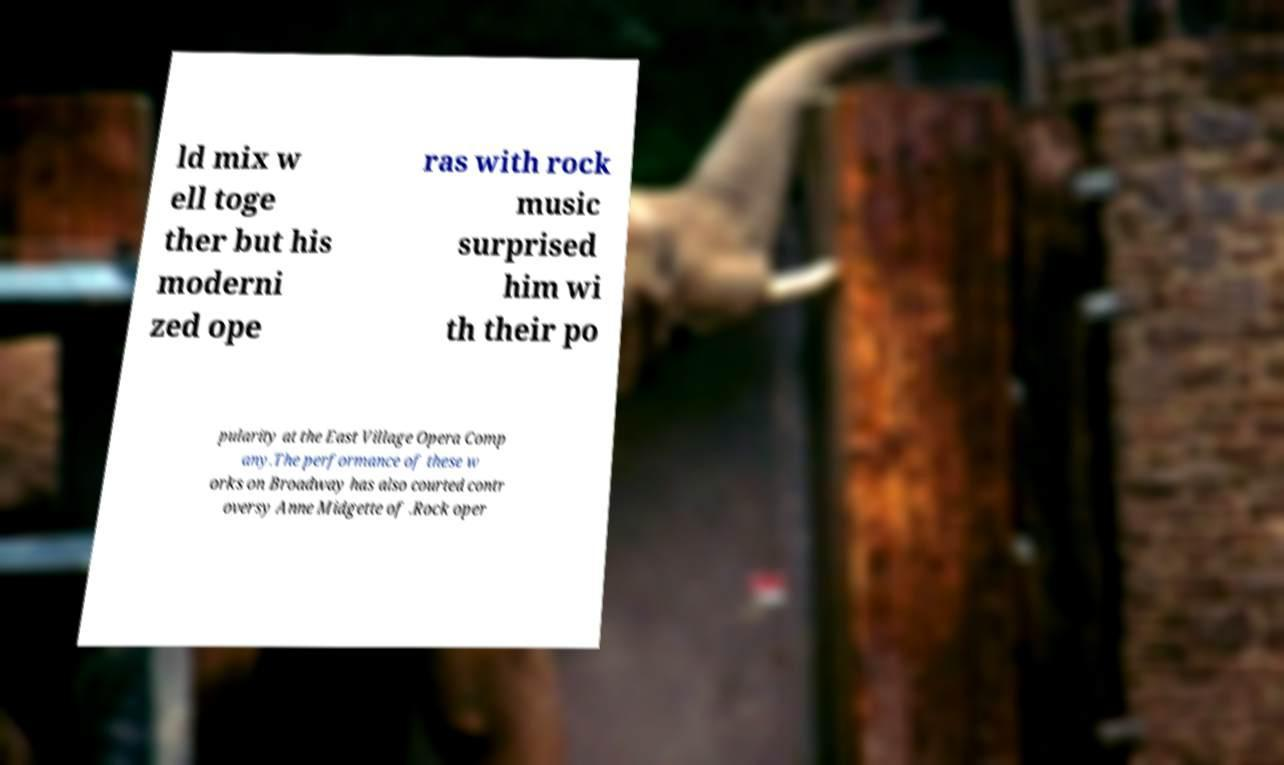Could you assist in decoding the text presented in this image and type it out clearly? ld mix w ell toge ther but his moderni zed ope ras with rock music surprised him wi th their po pularity at the East Village Opera Comp any.The performance of these w orks on Broadway has also courted contr oversy Anne Midgette of .Rock oper 